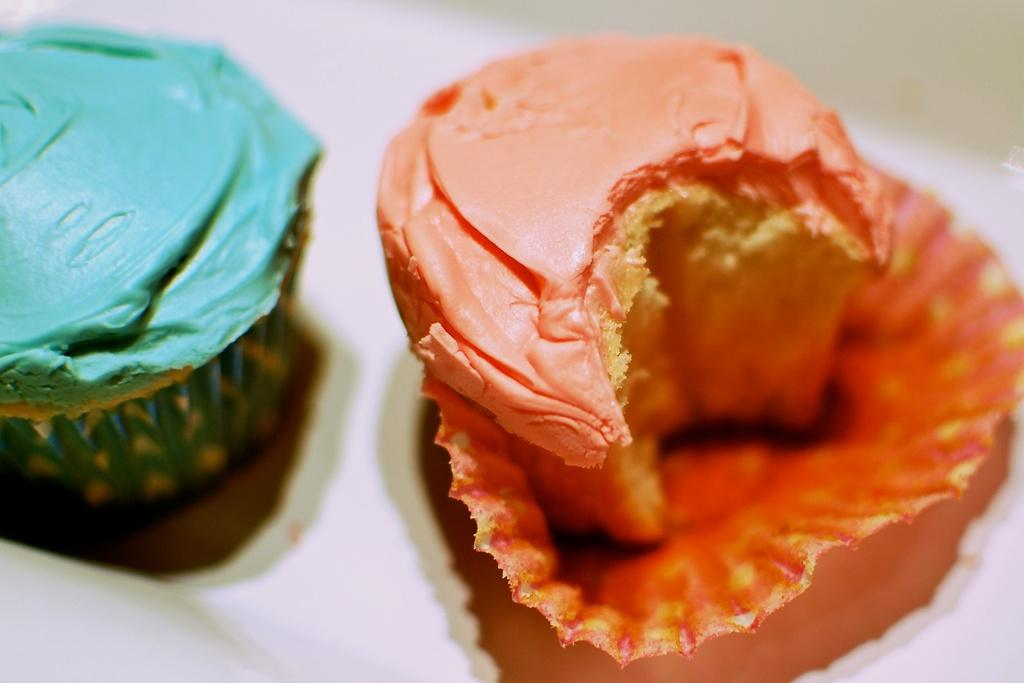How many cupcakes are in the image? There are two cupcakes in the image. What distinguishes the cupcakes from each other? The cupcakes are of different colors. Where are the cupcakes located in the image? The cupcakes are on a cover. What type of expert is shown in the image? There is no expert present in the image; it features two cupcakes on a cover. Can you tell me how many bedrooms are visible in the image? There are no bedrooms present in the image. 